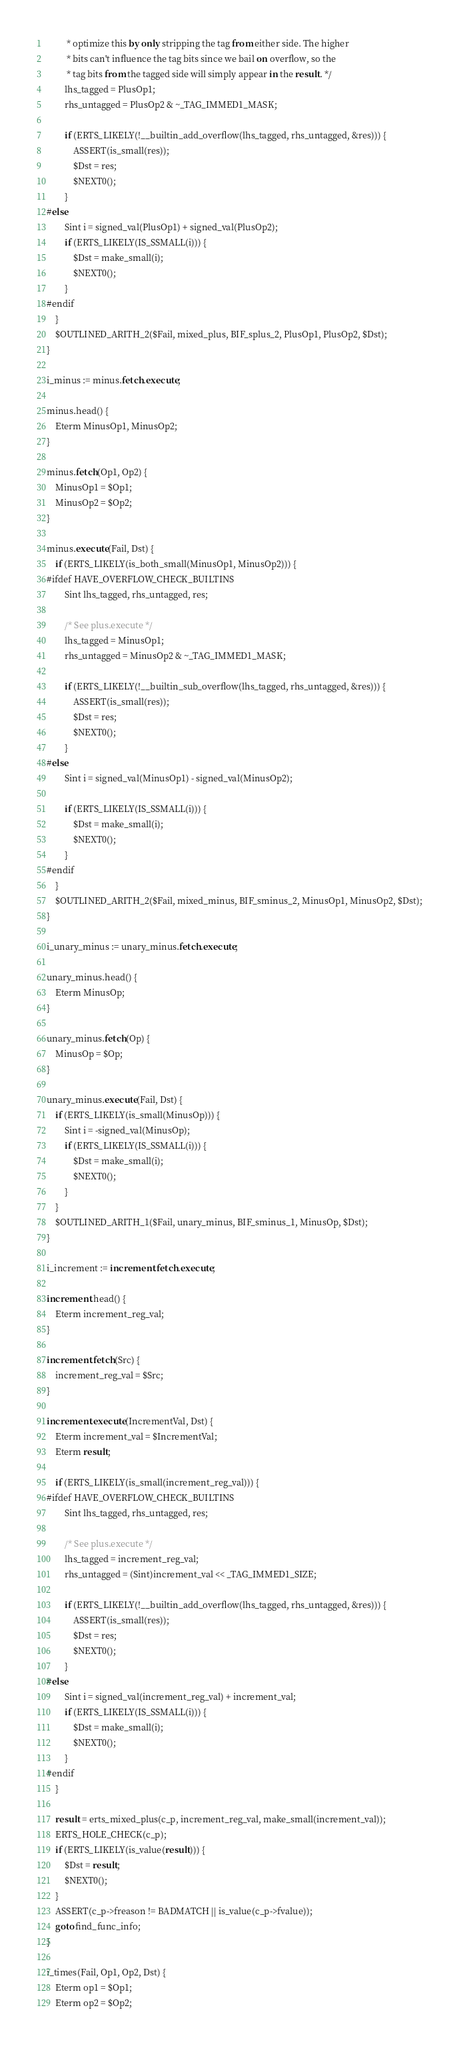Convert code to text. <code><loc_0><loc_0><loc_500><loc_500><_SQL_>         * optimize this by only stripping the tag from either side. The higher
         * bits can't influence the tag bits since we bail on overflow, so the
         * tag bits from the tagged side will simply appear in the result. */
        lhs_tagged = PlusOp1;
        rhs_untagged = PlusOp2 & ~_TAG_IMMED1_MASK;

        if (ERTS_LIKELY(!__builtin_add_overflow(lhs_tagged, rhs_untagged, &res))) {
            ASSERT(is_small(res));
            $Dst = res;
            $NEXT0();
        }
#else
        Sint i = signed_val(PlusOp1) + signed_val(PlusOp2);
        if (ERTS_LIKELY(IS_SSMALL(i))) {
            $Dst = make_small(i);
            $NEXT0();
        }
#endif
    }
    $OUTLINED_ARITH_2($Fail, mixed_plus, BIF_splus_2, PlusOp1, PlusOp2, $Dst);
}

i_minus := minus.fetch.execute;

minus.head() {
    Eterm MinusOp1, MinusOp2;
}

minus.fetch(Op1, Op2) {
    MinusOp1 = $Op1;
    MinusOp2 = $Op2;
}

minus.execute(Fail, Dst) {
    if (ERTS_LIKELY(is_both_small(MinusOp1, MinusOp2))) {
#ifdef HAVE_OVERFLOW_CHECK_BUILTINS
        Sint lhs_tagged, rhs_untagged, res;

        /* See plus.execute */
        lhs_tagged = MinusOp1;
        rhs_untagged = MinusOp2 & ~_TAG_IMMED1_MASK;

        if (ERTS_LIKELY(!__builtin_sub_overflow(lhs_tagged, rhs_untagged, &res))) {
            ASSERT(is_small(res));
            $Dst = res;
            $NEXT0();
        }
#else
        Sint i = signed_val(MinusOp1) - signed_val(MinusOp2);

        if (ERTS_LIKELY(IS_SSMALL(i))) {
            $Dst = make_small(i);
            $NEXT0();
        }
#endif
    }
    $OUTLINED_ARITH_2($Fail, mixed_minus, BIF_sminus_2, MinusOp1, MinusOp2, $Dst);
}

i_unary_minus := unary_minus.fetch.execute;

unary_minus.head() {
    Eterm MinusOp;
}

unary_minus.fetch(Op) {
    MinusOp = $Op;
}

unary_minus.execute(Fail, Dst) {
    if (ERTS_LIKELY(is_small(MinusOp))) {
        Sint i = -signed_val(MinusOp);
        if (ERTS_LIKELY(IS_SSMALL(i))) {
            $Dst = make_small(i);
            $NEXT0();
        }
    }
    $OUTLINED_ARITH_1($Fail, unary_minus, BIF_sminus_1, MinusOp, $Dst);
}

i_increment := increment.fetch.execute;

increment.head() {
    Eterm increment_reg_val;
}

increment.fetch(Src) {
    increment_reg_val = $Src;
}

increment.execute(IncrementVal, Dst) {
    Eterm increment_val = $IncrementVal;
    Eterm result;

    if (ERTS_LIKELY(is_small(increment_reg_val))) {
#ifdef HAVE_OVERFLOW_CHECK_BUILTINS
        Sint lhs_tagged, rhs_untagged, res;

        /* See plus.execute */
        lhs_tagged = increment_reg_val;
        rhs_untagged = (Sint)increment_val << _TAG_IMMED1_SIZE;

        if (ERTS_LIKELY(!__builtin_add_overflow(lhs_tagged, rhs_untagged, &res))) {
            ASSERT(is_small(res));
            $Dst = res;
            $NEXT0();
        }
#else
        Sint i = signed_val(increment_reg_val) + increment_val;
        if (ERTS_LIKELY(IS_SSMALL(i))) {
            $Dst = make_small(i);
            $NEXT0();
        }
#endif
    }

    result = erts_mixed_plus(c_p, increment_reg_val, make_small(increment_val));
    ERTS_HOLE_CHECK(c_p);
    if (ERTS_LIKELY(is_value(result))) {
        $Dst = result;
        $NEXT0();
    }
    ASSERT(c_p->freason != BADMATCH || is_value(c_p->fvalue));
    goto find_func_info;
}

i_times(Fail, Op1, Op2, Dst) {
    Eterm op1 = $Op1;
    Eterm op2 = $Op2;</code> 